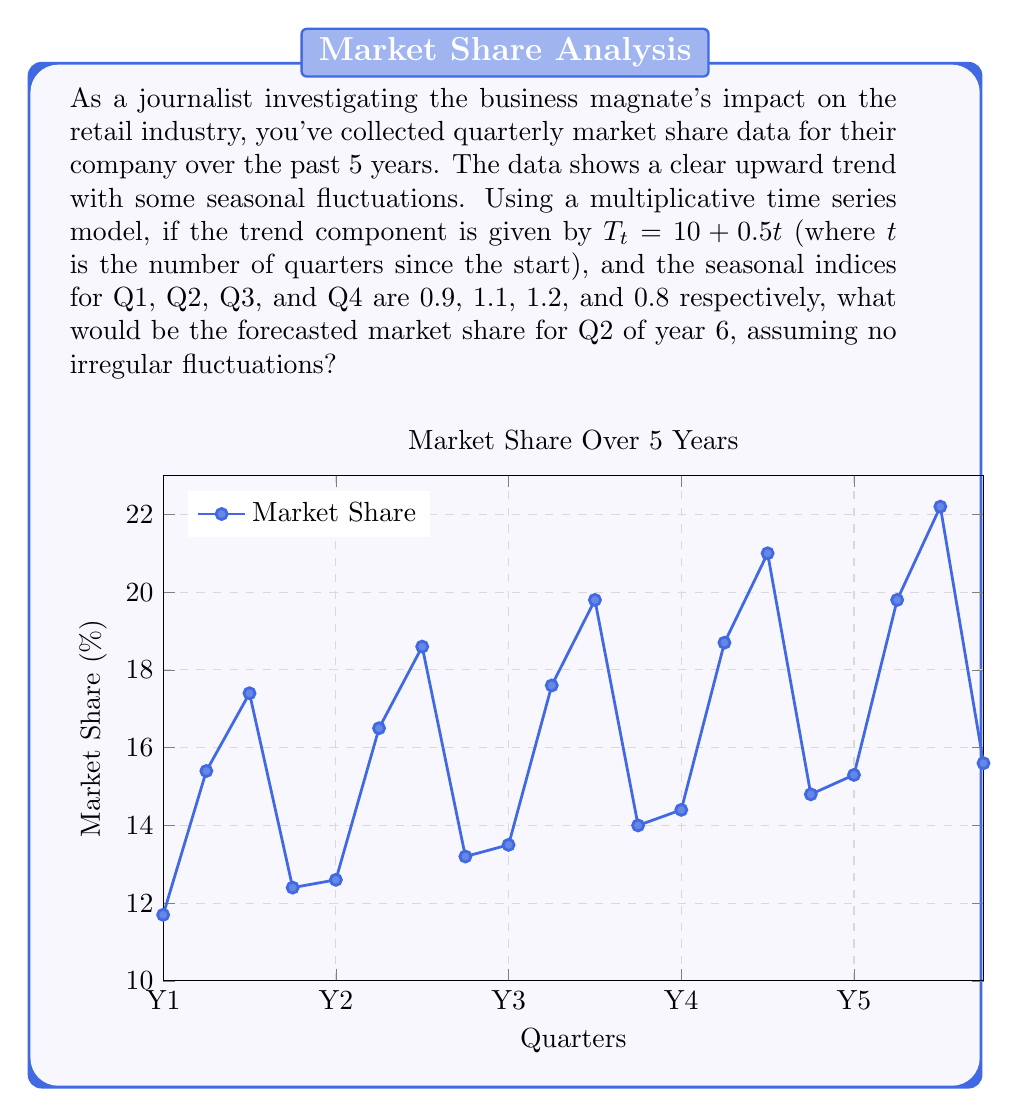Can you answer this question? Let's approach this step-by-step:

1) First, we need to determine which quarter of which year we're forecasting. Q2 of year 6 would be the 22nd quarter overall (5 years * 4 quarters + 2).

2) The trend component is given by $T_t = 10 + 0.5t$. For the 22nd quarter:

   $T_{22} = 10 + 0.5(22) = 21$

3) The seasonal index for Q2 is given as 1.1.

4) In a multiplicative model, we multiply the trend by the seasonal index:

   Forecast = Trend * Seasonal Index
   
   $F_{22} = T_{22} * S_2 = 21 * 1.1$

5) Calculate the final forecast:

   $F_{22} = 21 * 1.1 = 23.1$

Therefore, the forecasted market share for Q2 of year 6 is 23.1%.
Answer: 23.1% 